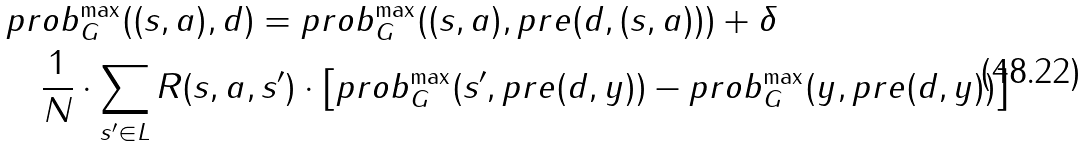<formula> <loc_0><loc_0><loc_500><loc_500>& p r o b ^ { \max } _ { G } ( ( s , a ) , d ) = p r o b ^ { \max } _ { G } ( ( s , a ) , p r e ( d , ( s , a ) ) ) + \delta \\ & \quad \frac { 1 } { N } \cdot \sum _ { s ^ { \prime } \in L } R ( s , a , s ^ { \prime } ) \cdot \left [ p r o b ^ { \max } _ { G } ( s ^ { \prime } , p r e ( d , y ) ) - p r o b ^ { \max } _ { G } ( y , p r e ( d , y ) ) \right ]</formula> 